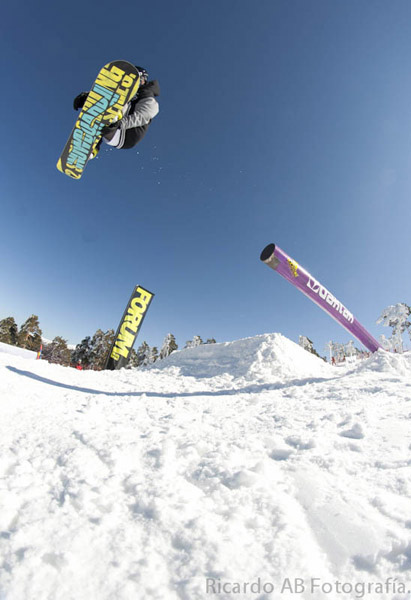Read all the text in this image. FORUM AB 